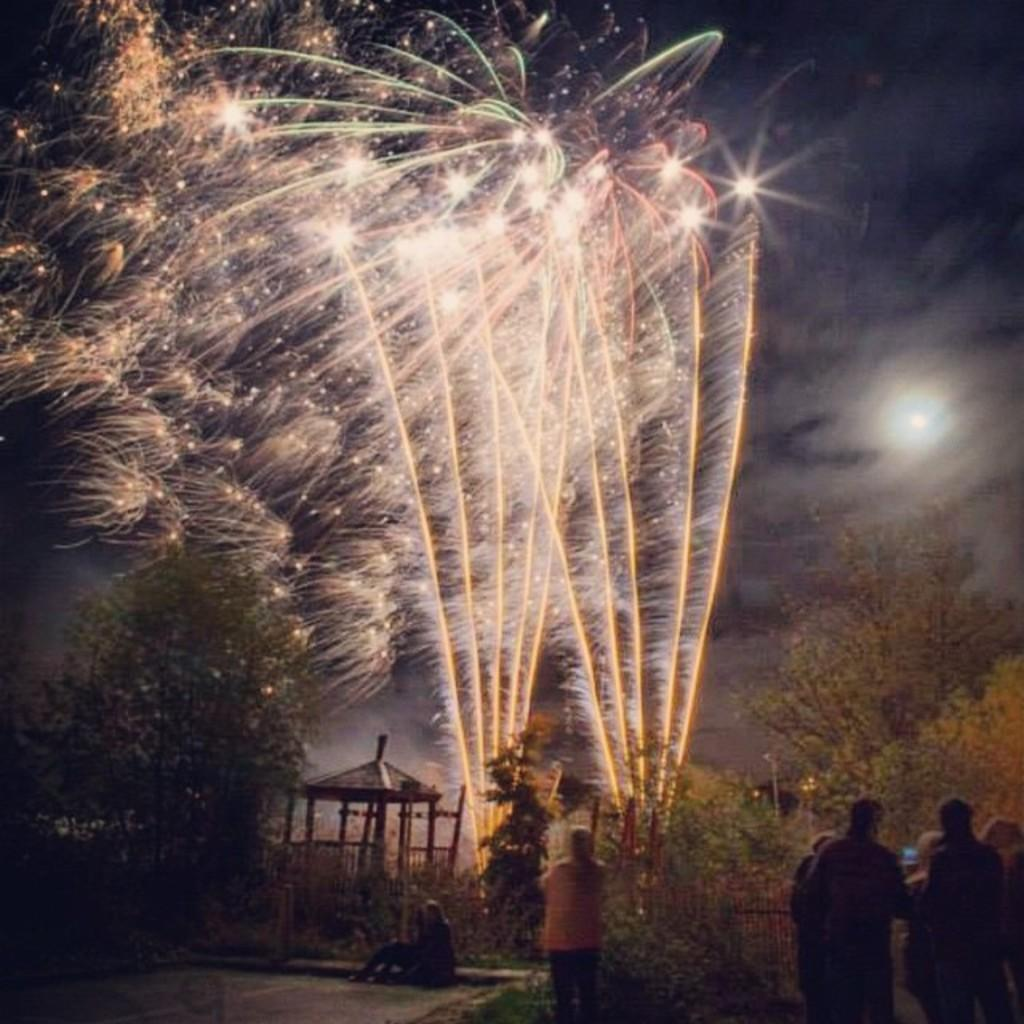Who or what can be seen in the image? There are people in the image. What type of natural elements are present in the image? There are trees and plants in the image. What can be seen in the distance in the image? The sky is visible in the background of the image. What is the main event or activity happening in the image? Fireworks are present in the image. What direction are the trucks moving in the image? There are no trucks present in the image. 